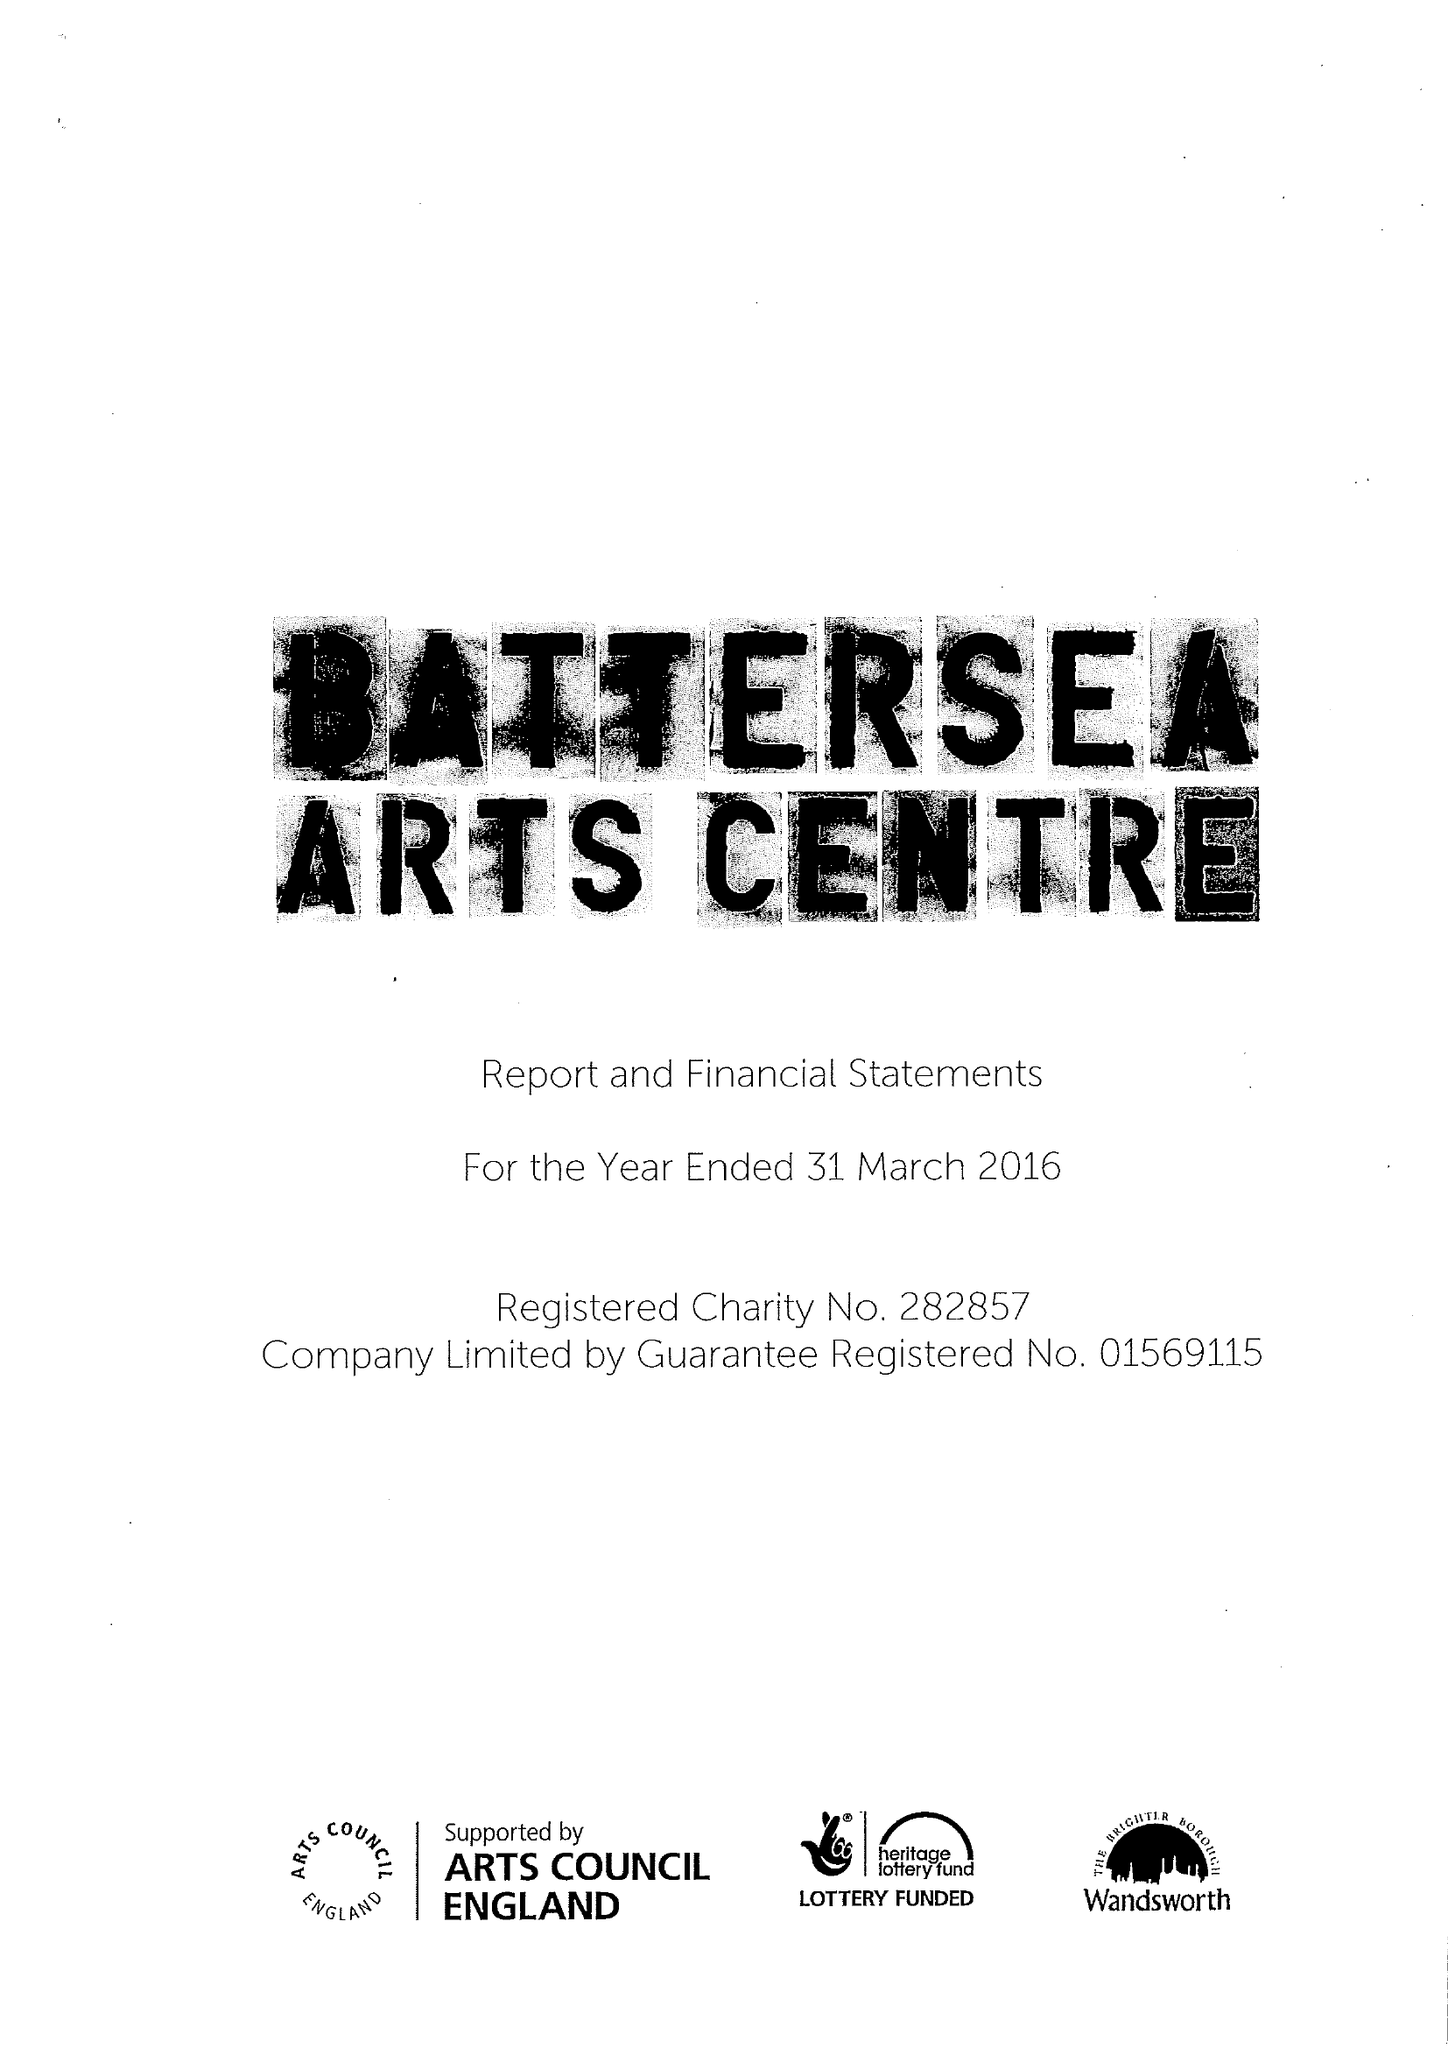What is the value for the address__street_line?
Answer the question using a single word or phrase. LAVENDER HILL 